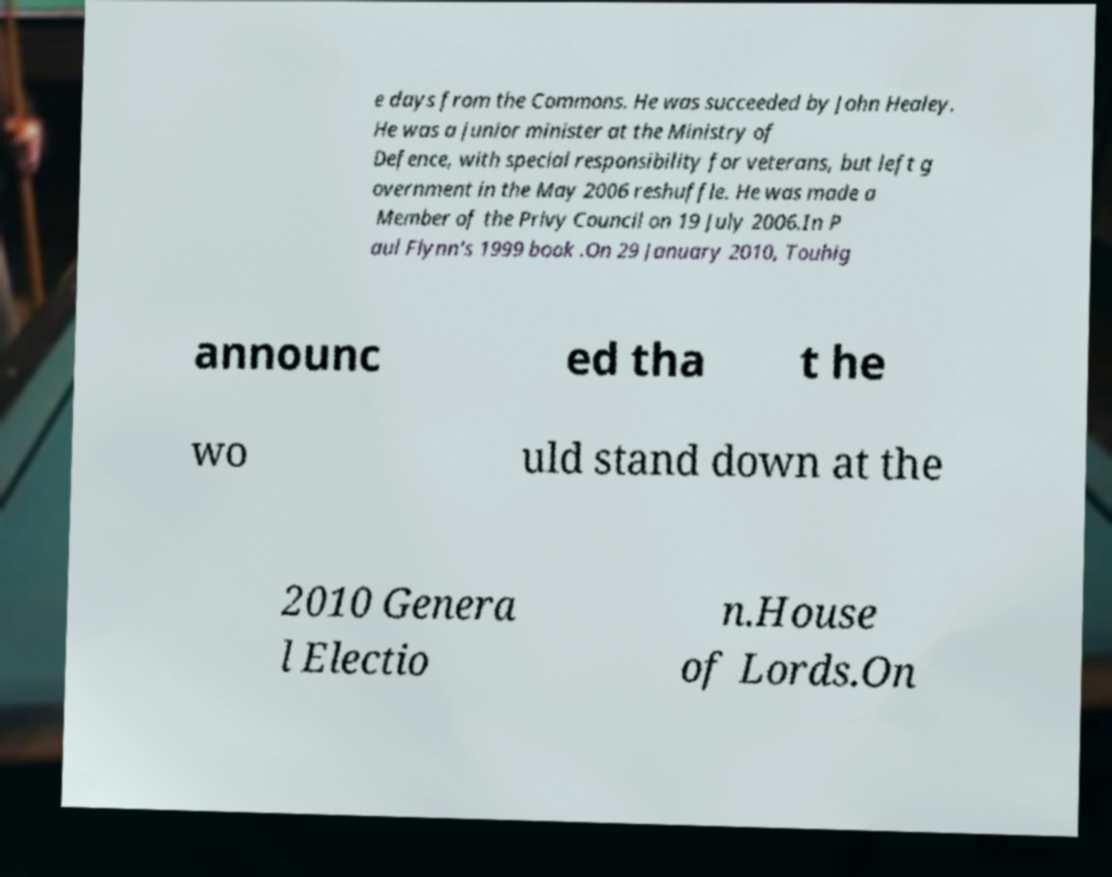Please identify and transcribe the text found in this image. e days from the Commons. He was succeeded by John Healey. He was a junior minister at the Ministry of Defence, with special responsibility for veterans, but left g overnment in the May 2006 reshuffle. He was made a Member of the Privy Council on 19 July 2006.In P aul Flynn's 1999 book .On 29 January 2010, Touhig announc ed tha t he wo uld stand down at the 2010 Genera l Electio n.House of Lords.On 